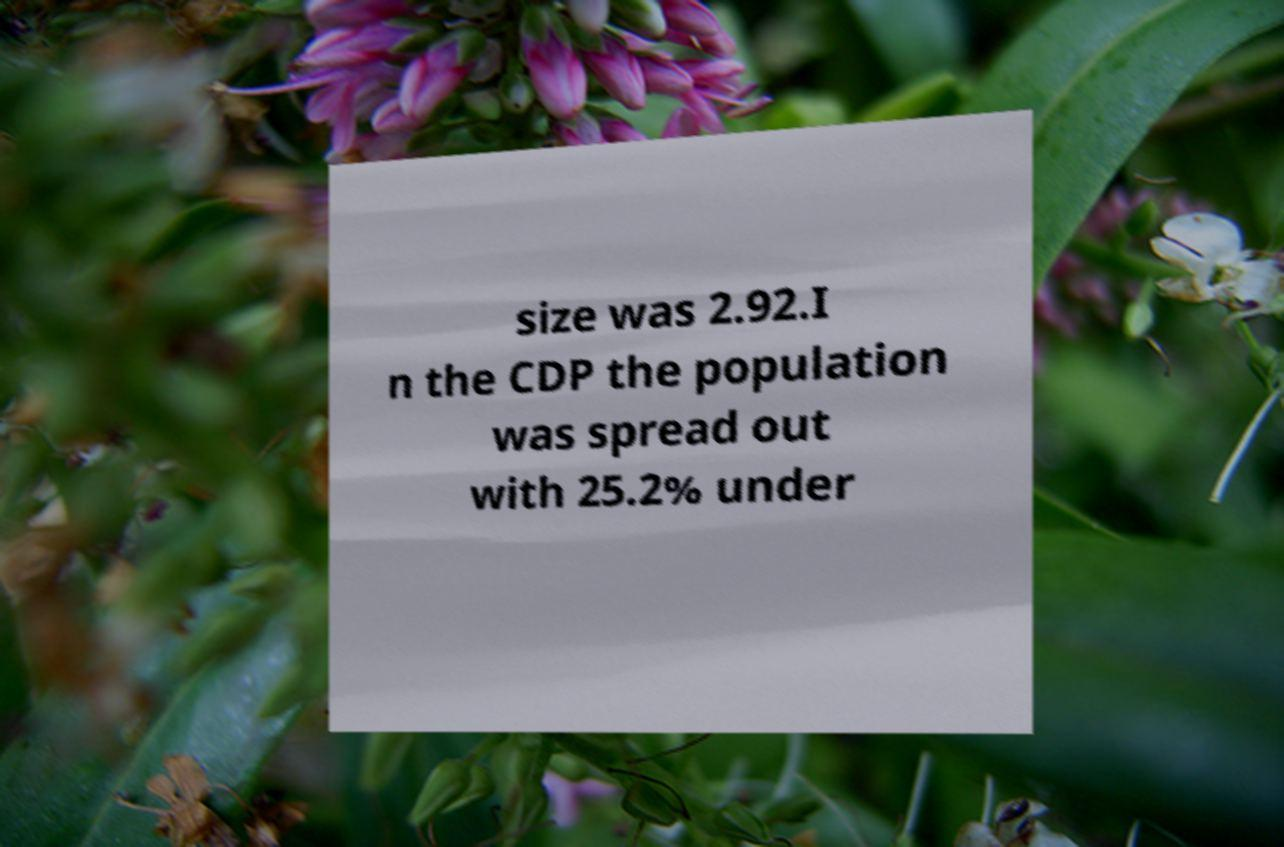There's text embedded in this image that I need extracted. Can you transcribe it verbatim? size was 2.92.I n the CDP the population was spread out with 25.2% under 